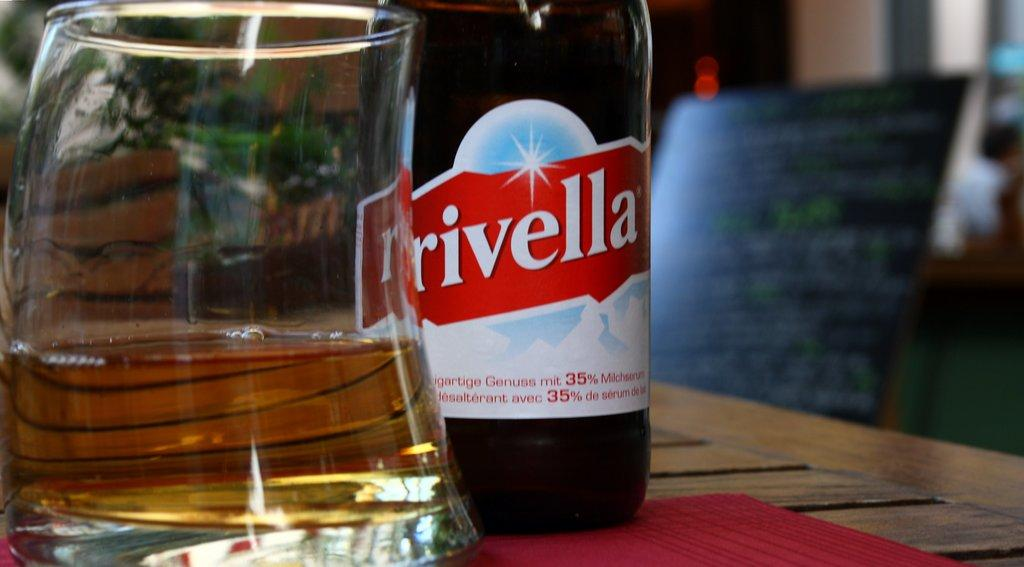<image>
Create a compact narrative representing the image presented. a glass and bottle of Rivella sit on a table 